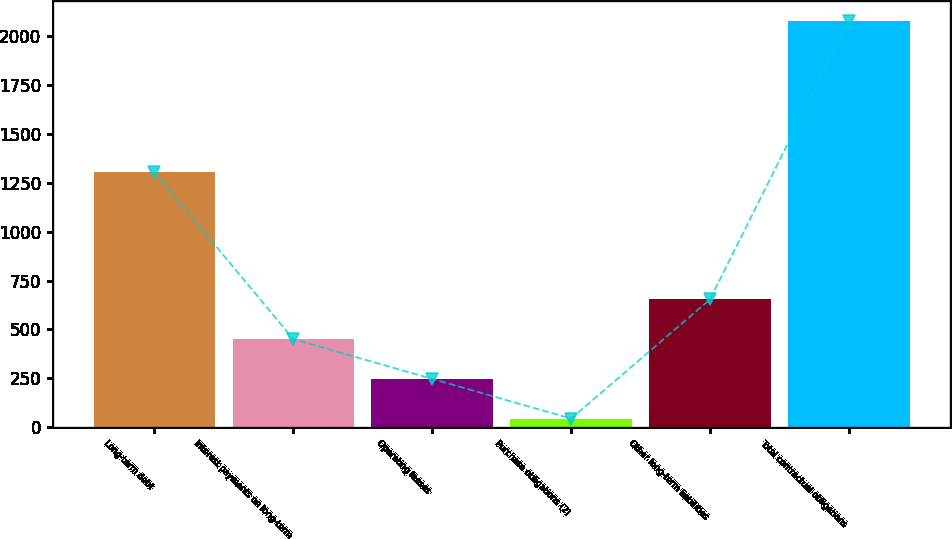Convert chart. <chart><loc_0><loc_0><loc_500><loc_500><bar_chart><fcel>Long-term debt<fcel>Interest payments on long-term<fcel>Operating leases<fcel>Purchase obligations (2)<fcel>Other long-term liabilities<fcel>Total contractual obligations<nl><fcel>1305<fcel>450.4<fcel>247.2<fcel>44<fcel>653.6<fcel>2076<nl></chart> 